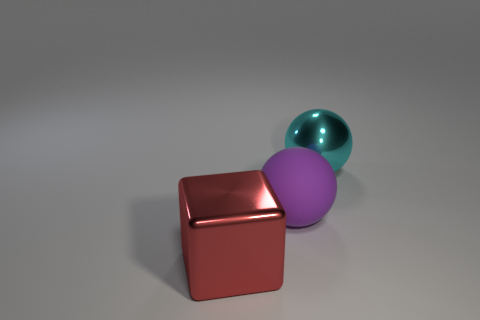Add 3 tiny red matte balls. How many objects exist? 6 Subtract all cubes. How many objects are left? 2 Subtract all large yellow metallic blocks. Subtract all purple rubber objects. How many objects are left? 2 Add 2 cyan shiny objects. How many cyan shiny objects are left? 3 Add 3 large cyan metallic objects. How many large cyan metallic objects exist? 4 Subtract 0 red balls. How many objects are left? 3 